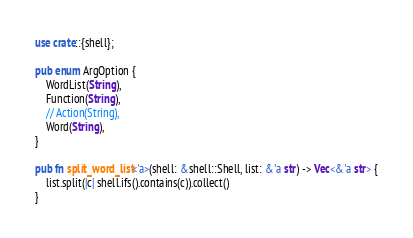Convert code to text. <code><loc_0><loc_0><loc_500><loc_500><_Rust_>use crate::{shell};

pub enum ArgOption {
    WordList(String),
    Function(String),
    // Action(String),
    Word(String),
}

pub fn split_word_list<'a>(shell: &shell::Shell, list: &'a str) -> Vec<&'a str> {
    list.split(|c| shell.ifs().contains(c)).collect()
}</code> 